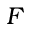Convert formula to latex. <formula><loc_0><loc_0><loc_500><loc_500>F</formula> 